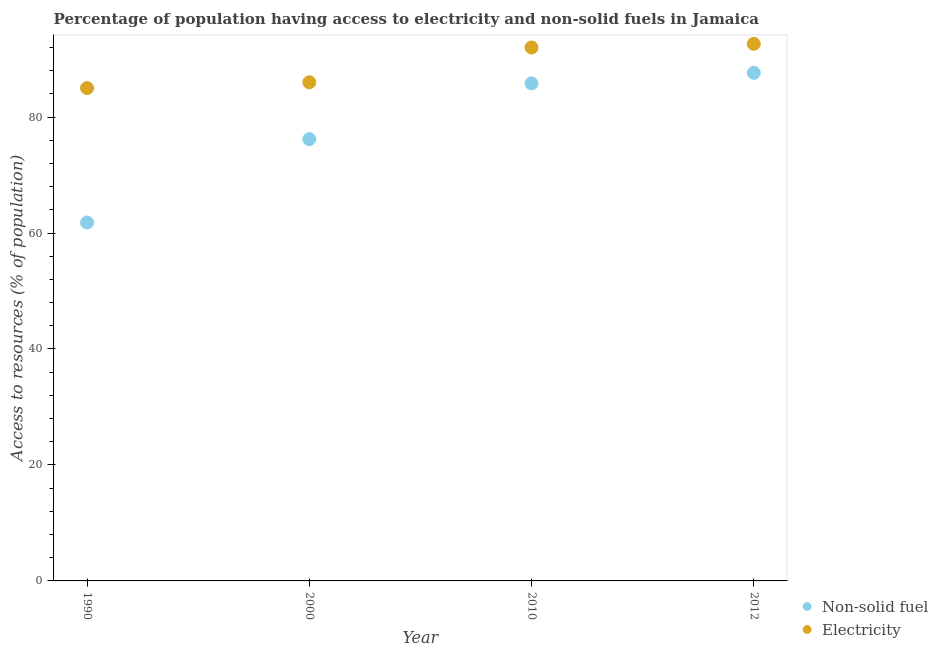What is the percentage of population having access to non-solid fuel in 1990?
Make the answer very short. 61.81. Across all years, what is the maximum percentage of population having access to electricity?
Provide a succinct answer. 92.63. In which year was the percentage of population having access to electricity maximum?
Make the answer very short. 2012. What is the total percentage of population having access to electricity in the graph?
Offer a very short reply. 355.63. What is the difference between the percentage of population having access to non-solid fuel in 1990 and that in 2012?
Ensure brevity in your answer.  -25.82. What is the difference between the percentage of population having access to electricity in 1990 and the percentage of population having access to non-solid fuel in 2012?
Give a very brief answer. -2.63. What is the average percentage of population having access to non-solid fuel per year?
Make the answer very short. 77.86. In the year 2000, what is the difference between the percentage of population having access to non-solid fuel and percentage of population having access to electricity?
Provide a succinct answer. -9.81. In how many years, is the percentage of population having access to electricity greater than 44 %?
Your answer should be compact. 4. What is the ratio of the percentage of population having access to electricity in 2000 to that in 2012?
Give a very brief answer. 0.93. What is the difference between the highest and the second highest percentage of population having access to non-solid fuel?
Make the answer very short. 1.81. What is the difference between the highest and the lowest percentage of population having access to non-solid fuel?
Your response must be concise. 25.82. In how many years, is the percentage of population having access to non-solid fuel greater than the average percentage of population having access to non-solid fuel taken over all years?
Your response must be concise. 2. Is the percentage of population having access to electricity strictly greater than the percentage of population having access to non-solid fuel over the years?
Offer a terse response. Yes. Is the percentage of population having access to electricity strictly less than the percentage of population having access to non-solid fuel over the years?
Ensure brevity in your answer.  No. What is the difference between two consecutive major ticks on the Y-axis?
Give a very brief answer. 20. Does the graph contain any zero values?
Your response must be concise. No. Does the graph contain grids?
Keep it short and to the point. No. Where does the legend appear in the graph?
Offer a terse response. Bottom right. How many legend labels are there?
Your answer should be compact. 2. What is the title of the graph?
Provide a short and direct response. Percentage of population having access to electricity and non-solid fuels in Jamaica. Does "Chemicals" appear as one of the legend labels in the graph?
Ensure brevity in your answer.  No. What is the label or title of the X-axis?
Make the answer very short. Year. What is the label or title of the Y-axis?
Ensure brevity in your answer.  Access to resources (% of population). What is the Access to resources (% of population) of Non-solid fuel in 1990?
Provide a short and direct response. 61.81. What is the Access to resources (% of population) in Electricity in 1990?
Offer a terse response. 85. What is the Access to resources (% of population) in Non-solid fuel in 2000?
Ensure brevity in your answer.  76.19. What is the Access to resources (% of population) of Electricity in 2000?
Give a very brief answer. 86. What is the Access to resources (% of population) in Non-solid fuel in 2010?
Make the answer very short. 85.82. What is the Access to resources (% of population) in Electricity in 2010?
Provide a succinct answer. 92. What is the Access to resources (% of population) of Non-solid fuel in 2012?
Give a very brief answer. 87.63. What is the Access to resources (% of population) in Electricity in 2012?
Offer a terse response. 92.63. Across all years, what is the maximum Access to resources (% of population) in Non-solid fuel?
Keep it short and to the point. 87.63. Across all years, what is the maximum Access to resources (% of population) of Electricity?
Ensure brevity in your answer.  92.63. Across all years, what is the minimum Access to resources (% of population) in Non-solid fuel?
Keep it short and to the point. 61.81. What is the total Access to resources (% of population) in Non-solid fuel in the graph?
Ensure brevity in your answer.  311.44. What is the total Access to resources (% of population) in Electricity in the graph?
Offer a very short reply. 355.63. What is the difference between the Access to resources (% of population) of Non-solid fuel in 1990 and that in 2000?
Offer a very short reply. -14.38. What is the difference between the Access to resources (% of population) of Non-solid fuel in 1990 and that in 2010?
Provide a short and direct response. -24.01. What is the difference between the Access to resources (% of population) in Non-solid fuel in 1990 and that in 2012?
Provide a succinct answer. -25.82. What is the difference between the Access to resources (% of population) of Electricity in 1990 and that in 2012?
Your response must be concise. -7.63. What is the difference between the Access to resources (% of population) of Non-solid fuel in 2000 and that in 2010?
Ensure brevity in your answer.  -9.62. What is the difference between the Access to resources (% of population) of Electricity in 2000 and that in 2010?
Your answer should be very brief. -6. What is the difference between the Access to resources (% of population) in Non-solid fuel in 2000 and that in 2012?
Make the answer very short. -11.44. What is the difference between the Access to resources (% of population) in Electricity in 2000 and that in 2012?
Keep it short and to the point. -6.63. What is the difference between the Access to resources (% of population) of Non-solid fuel in 2010 and that in 2012?
Your answer should be very brief. -1.81. What is the difference between the Access to resources (% of population) in Electricity in 2010 and that in 2012?
Ensure brevity in your answer.  -0.63. What is the difference between the Access to resources (% of population) of Non-solid fuel in 1990 and the Access to resources (% of population) of Electricity in 2000?
Keep it short and to the point. -24.19. What is the difference between the Access to resources (% of population) of Non-solid fuel in 1990 and the Access to resources (% of population) of Electricity in 2010?
Keep it short and to the point. -30.19. What is the difference between the Access to resources (% of population) of Non-solid fuel in 1990 and the Access to resources (% of population) of Electricity in 2012?
Offer a terse response. -30.82. What is the difference between the Access to resources (% of population) of Non-solid fuel in 2000 and the Access to resources (% of population) of Electricity in 2010?
Provide a succinct answer. -15.81. What is the difference between the Access to resources (% of population) of Non-solid fuel in 2000 and the Access to resources (% of population) of Electricity in 2012?
Provide a short and direct response. -16.44. What is the difference between the Access to resources (% of population) of Non-solid fuel in 2010 and the Access to resources (% of population) of Electricity in 2012?
Make the answer very short. -6.82. What is the average Access to resources (% of population) of Non-solid fuel per year?
Make the answer very short. 77.86. What is the average Access to resources (% of population) of Electricity per year?
Offer a terse response. 88.91. In the year 1990, what is the difference between the Access to resources (% of population) in Non-solid fuel and Access to resources (% of population) in Electricity?
Your answer should be compact. -23.19. In the year 2000, what is the difference between the Access to resources (% of population) of Non-solid fuel and Access to resources (% of population) of Electricity?
Offer a terse response. -9.81. In the year 2010, what is the difference between the Access to resources (% of population) of Non-solid fuel and Access to resources (% of population) of Electricity?
Offer a very short reply. -6.18. In the year 2012, what is the difference between the Access to resources (% of population) of Non-solid fuel and Access to resources (% of population) of Electricity?
Your answer should be very brief. -5.01. What is the ratio of the Access to resources (% of population) of Non-solid fuel in 1990 to that in 2000?
Provide a succinct answer. 0.81. What is the ratio of the Access to resources (% of population) in Electricity in 1990 to that in 2000?
Give a very brief answer. 0.99. What is the ratio of the Access to resources (% of population) of Non-solid fuel in 1990 to that in 2010?
Your answer should be very brief. 0.72. What is the ratio of the Access to resources (% of population) of Electricity in 1990 to that in 2010?
Give a very brief answer. 0.92. What is the ratio of the Access to resources (% of population) of Non-solid fuel in 1990 to that in 2012?
Give a very brief answer. 0.71. What is the ratio of the Access to resources (% of population) of Electricity in 1990 to that in 2012?
Your response must be concise. 0.92. What is the ratio of the Access to resources (% of population) in Non-solid fuel in 2000 to that in 2010?
Your answer should be very brief. 0.89. What is the ratio of the Access to resources (% of population) of Electricity in 2000 to that in 2010?
Give a very brief answer. 0.93. What is the ratio of the Access to resources (% of population) of Non-solid fuel in 2000 to that in 2012?
Ensure brevity in your answer.  0.87. What is the ratio of the Access to resources (% of population) in Electricity in 2000 to that in 2012?
Make the answer very short. 0.93. What is the ratio of the Access to resources (% of population) of Non-solid fuel in 2010 to that in 2012?
Provide a succinct answer. 0.98. What is the difference between the highest and the second highest Access to resources (% of population) in Non-solid fuel?
Provide a succinct answer. 1.81. What is the difference between the highest and the second highest Access to resources (% of population) of Electricity?
Keep it short and to the point. 0.63. What is the difference between the highest and the lowest Access to resources (% of population) of Non-solid fuel?
Make the answer very short. 25.82. What is the difference between the highest and the lowest Access to resources (% of population) of Electricity?
Make the answer very short. 7.63. 